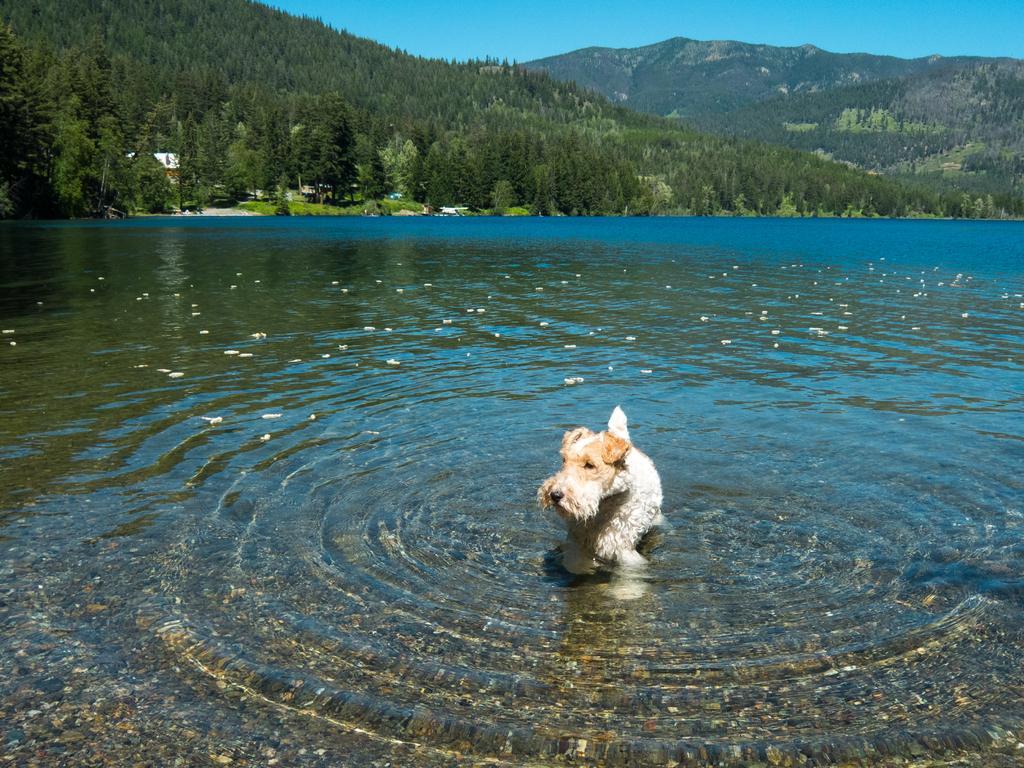Could you give a brief overview of what you see in this image? This image is taken outdoors. At the top of the image there is a sky. In the background there are a few hills. There are many trees and plants. At the bottom of the image there is a pond with water and in the middle of the image there is a dog in the pond. 